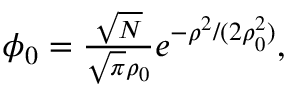Convert formula to latex. <formula><loc_0><loc_0><loc_500><loc_500>\begin{array} { r } { \phi _ { 0 } = \frac { \sqrt { N } } { \sqrt { \pi } \rho _ { 0 } } e ^ { - \rho ^ { 2 } / ( 2 \rho _ { 0 } ^ { 2 } ) } , } \end{array}</formula> 